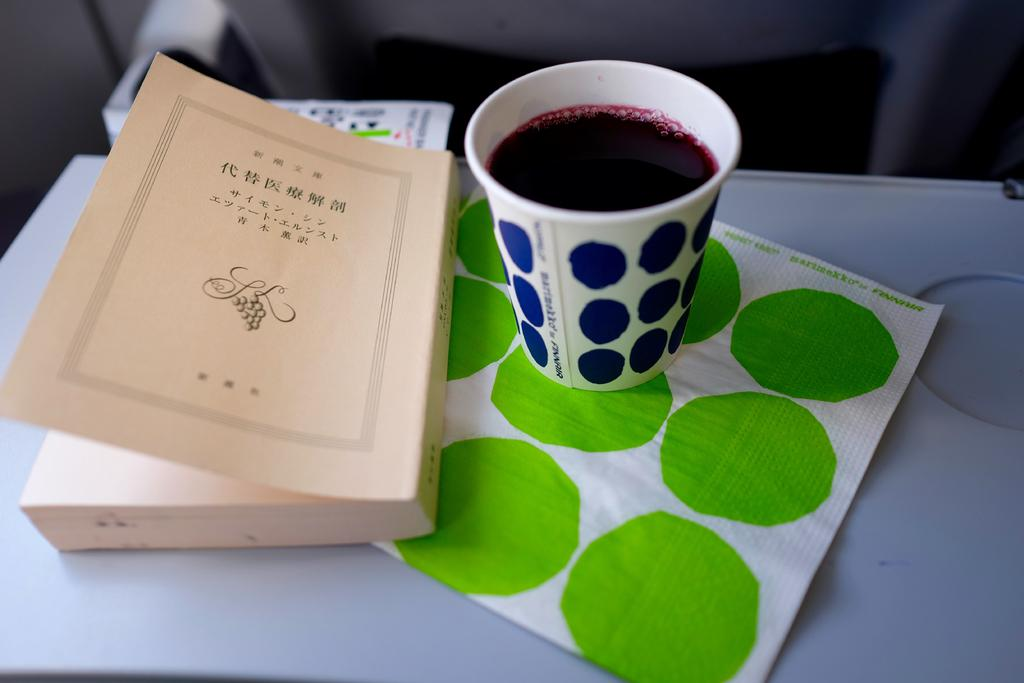What object can be seen in the image that is typically used for reading? There is a book in the image that is typically used for reading. What object in the image might be used for drinking? There is a glass in the image that might be used for drinking. What is inside the glass in the image? There is a liquid in the glass in the image. What type of material is present in the image that is often used for cleaning or wiping? There is tissue paper in the image that is often used for cleaning or wiping. What color is the surface on which the objects are placed in the image? The surface in the image is white. Can you describe the background of the image? The background of the image is blurred. Are there any toys visible in the image? No, there are no toys present in the image. Can you see a horn in the image? No, there is no horn present in the image. 